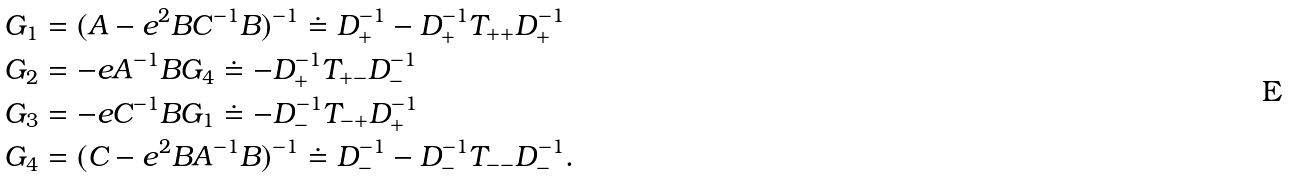Convert formula to latex. <formula><loc_0><loc_0><loc_500><loc_500>G _ { 1 } & = ( A - e ^ { 2 } B C ^ { - 1 } B ) ^ { - 1 } \doteq D _ { + } ^ { - 1 } - D _ { + } ^ { - 1 } T _ { + + } D _ { + } ^ { - 1 } \\ G _ { 2 } & = - e A ^ { - 1 } B G _ { 4 } \doteq - D _ { + } ^ { - 1 } T _ { + - } D _ { - } ^ { - 1 } \\ G _ { 3 } & = - e C ^ { - 1 } B G _ { 1 } \doteq - D _ { - } ^ { - 1 } T _ { - + } D _ { + } ^ { - 1 } \\ G _ { 4 } & = ( C - e ^ { 2 } B A ^ { - 1 } B ) ^ { - 1 } \doteq D _ { - } ^ { - 1 } - D _ { - } ^ { - 1 } T _ { - - } D _ { - } ^ { - 1 } .</formula> 